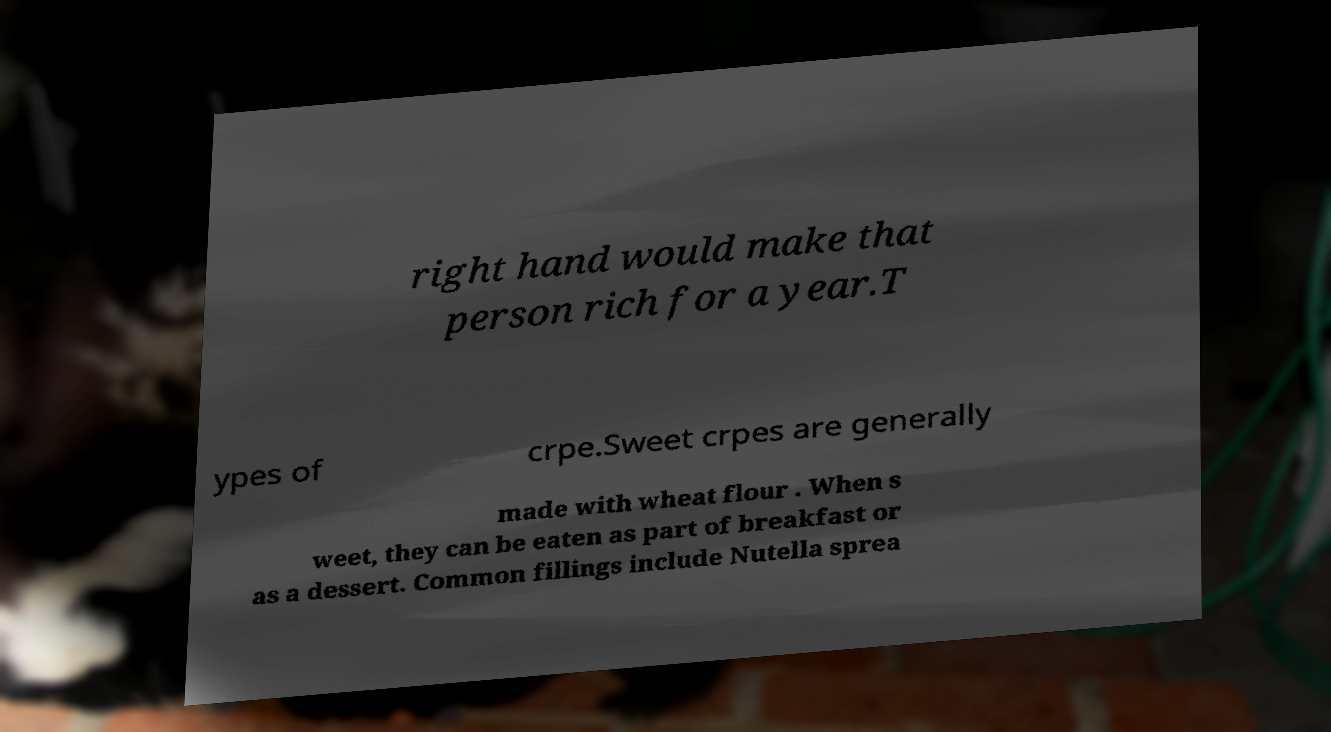Please identify and transcribe the text found in this image. right hand would make that person rich for a year.T ypes of crpe.Sweet crpes are generally made with wheat flour . When s weet, they can be eaten as part of breakfast or as a dessert. Common fillings include Nutella sprea 